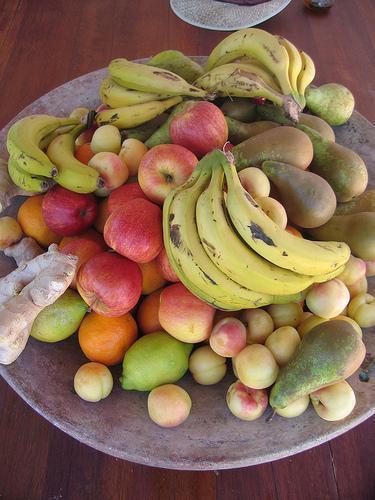How many different types of fruit are shown in this photo?
Give a very brief answer. 6. 